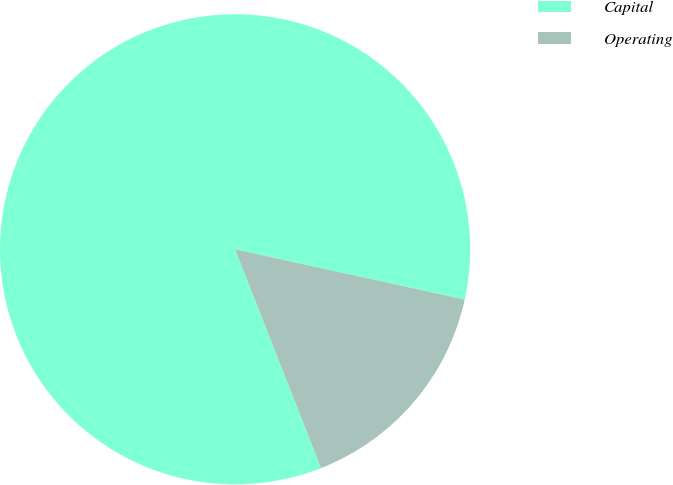Convert chart. <chart><loc_0><loc_0><loc_500><loc_500><pie_chart><fcel>Capital<fcel>Operating<nl><fcel>84.39%<fcel>15.61%<nl></chart> 